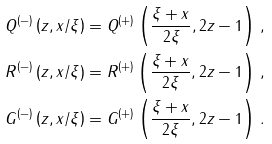<formula> <loc_0><loc_0><loc_500><loc_500>Q ^ { ( - ) } \left ( z , x / \xi \right ) & = Q ^ { ( + ) } \left ( \frac { \xi + x } { 2 \xi } , 2 z - 1 \right ) \, , \\ R ^ { ( - ) } \left ( z , x / \xi \right ) & = R ^ { ( + ) } \left ( \frac { \xi + x } { 2 \xi } , 2 z - 1 \right ) \, , \\ G ^ { ( - ) } \left ( z , x / \xi \right ) & = G ^ { ( + ) } \left ( \frac { \xi + x } { 2 \xi } , 2 z - 1 \right ) \, .</formula> 